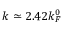<formula> <loc_0><loc_0><loc_500><loc_500>k \simeq 2 . 4 2 k _ { F } ^ { 0 }</formula> 